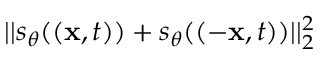Convert formula to latex. <formula><loc_0><loc_0><loc_500><loc_500>| | s _ { \theta } ( ( x , t ) ) + s _ { \theta } ( ( - x , t ) ) | | _ { 2 } ^ { 2 }</formula> 